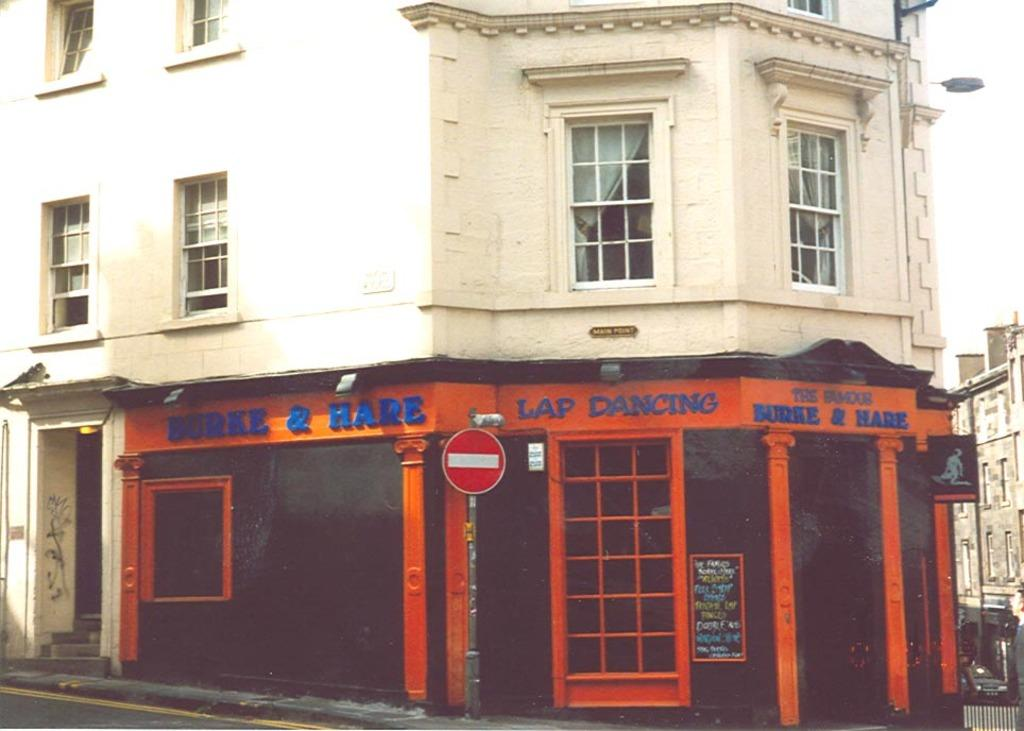What type of structure is visible in the image? There is a building in the image. What features can be seen on the building? The building has windows and doors. Is there any text visible on the building? Yes, there is text on the building. Can you tell me how many pens are on the shelf in the image? There is no shelf or pen present in the image; it only features a building with text and windows. 